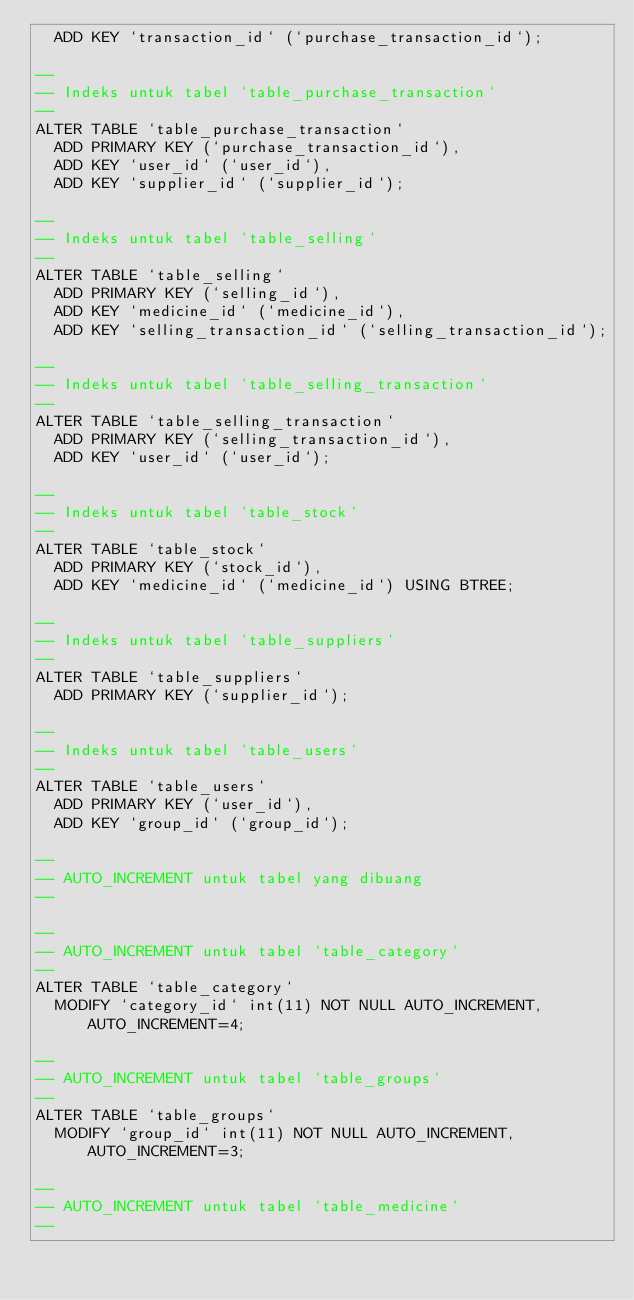<code> <loc_0><loc_0><loc_500><loc_500><_SQL_>  ADD KEY `transaction_id` (`purchase_transaction_id`);

--
-- Indeks untuk tabel `table_purchase_transaction`
--
ALTER TABLE `table_purchase_transaction`
  ADD PRIMARY KEY (`purchase_transaction_id`),
  ADD KEY `user_id` (`user_id`),
  ADD KEY `supplier_id` (`supplier_id`);

--
-- Indeks untuk tabel `table_selling`
--
ALTER TABLE `table_selling`
  ADD PRIMARY KEY (`selling_id`),
  ADD KEY `medicine_id` (`medicine_id`),
  ADD KEY `selling_transaction_id` (`selling_transaction_id`);

--
-- Indeks untuk tabel `table_selling_transaction`
--
ALTER TABLE `table_selling_transaction`
  ADD PRIMARY KEY (`selling_transaction_id`),
  ADD KEY `user_id` (`user_id`);

--
-- Indeks untuk tabel `table_stock`
--
ALTER TABLE `table_stock`
  ADD PRIMARY KEY (`stock_id`),
  ADD KEY `medicine_id` (`medicine_id`) USING BTREE;

--
-- Indeks untuk tabel `table_suppliers`
--
ALTER TABLE `table_suppliers`
  ADD PRIMARY KEY (`supplier_id`);

--
-- Indeks untuk tabel `table_users`
--
ALTER TABLE `table_users`
  ADD PRIMARY KEY (`user_id`),
  ADD KEY `group_id` (`group_id`);

--
-- AUTO_INCREMENT untuk tabel yang dibuang
--

--
-- AUTO_INCREMENT untuk tabel `table_category`
--
ALTER TABLE `table_category`
  MODIFY `category_id` int(11) NOT NULL AUTO_INCREMENT, AUTO_INCREMENT=4;

--
-- AUTO_INCREMENT untuk tabel `table_groups`
--
ALTER TABLE `table_groups`
  MODIFY `group_id` int(11) NOT NULL AUTO_INCREMENT, AUTO_INCREMENT=3;

--
-- AUTO_INCREMENT untuk tabel `table_medicine`
--</code> 